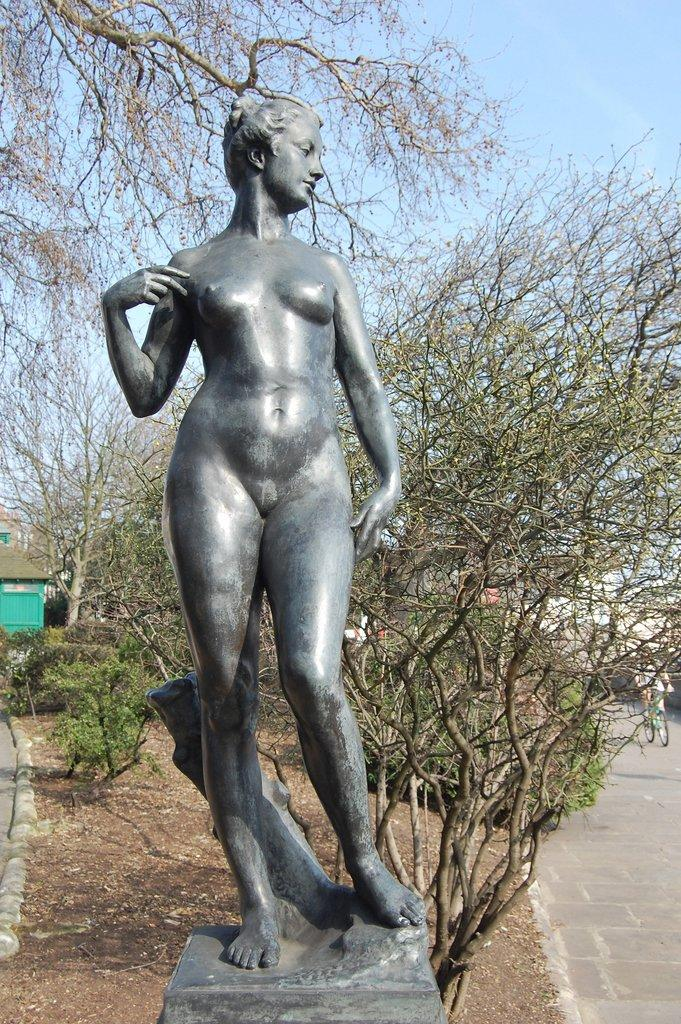What is the main subject in the image? There is a statue of a woman in the image. What can be seen in the background behind the statue? There are trees and plants behind the statue. Is there any other activity or subject visible in the image? Yes, there is a person riding a bicycle in the right corner of the image. What type of news can be seen on the roof in the image? There is no roof or news present in the image; it features a statue of a woman, trees and plants in the background, and a person riding a bicycle in the right corner. 